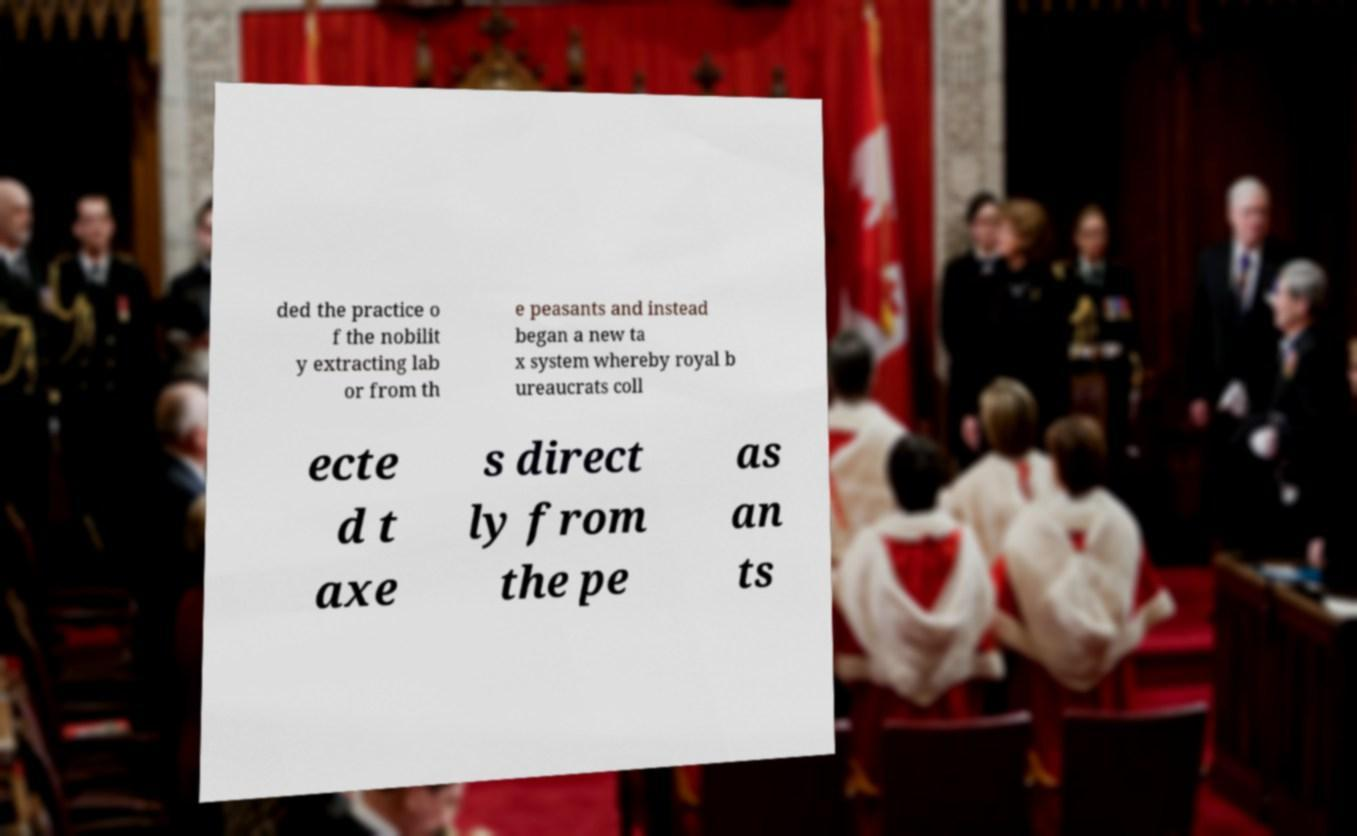Please read and relay the text visible in this image. What does it say? ded the practice o f the nobilit y extracting lab or from th e peasants and instead began a new ta x system whereby royal b ureaucrats coll ecte d t axe s direct ly from the pe as an ts 